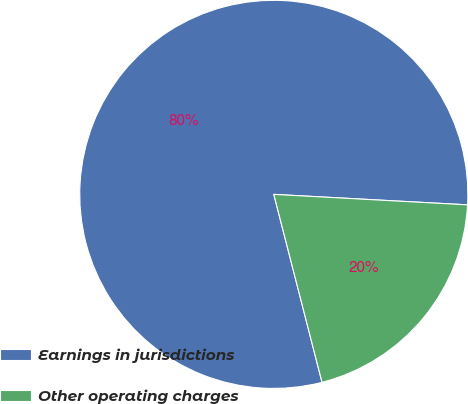<chart> <loc_0><loc_0><loc_500><loc_500><pie_chart><fcel>Earnings in jurisdictions<fcel>Other operating charges<nl><fcel>79.86%<fcel>20.14%<nl></chart> 